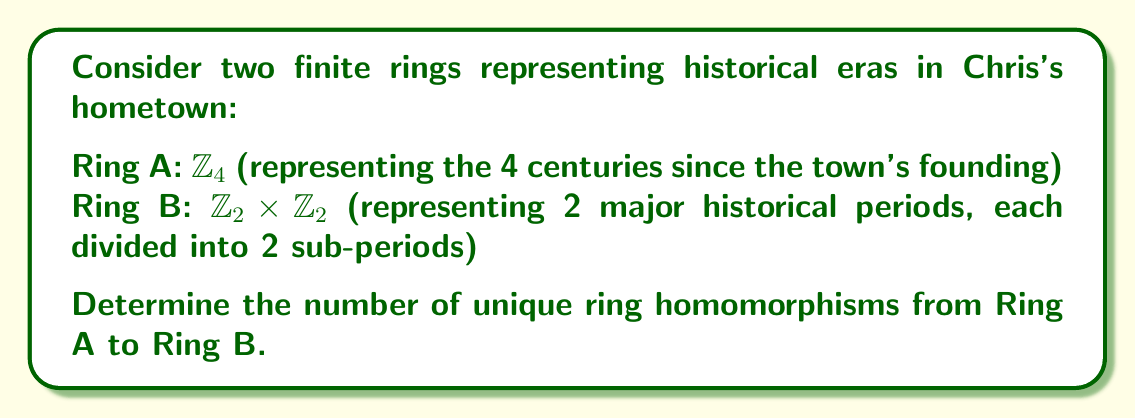Show me your answer to this math problem. 1) First, recall that a ring homomorphism $f: \mathbb{Z}_4 \to \mathbb{Z}_2 \times \mathbb{Z}_2$ must satisfy:
   a) $f(0) = (0,0)$
   b) $f(a+b) = f(a) + f(b)$
   c) $f(ab) = f(a)f(b)$

2) In $\mathbb{Z}_4$, we only need to determine $f(1)$, as:
   $f(2) = f(1+1) = f(1) + f(1)$
   $f(3) = f(-1) = -f(1)$

3) The possible values for $f(1)$ in $\mathbb{Z}_2 \times \mathbb{Z}_2$ are:
   $(0,0)$, $(1,0)$, $(0,1)$, $(1,1)$

4) Check each possibility:
   a) If $f(1) = (0,0)$:
      $f(2) = (0,0) + (0,0) = (0,0)$
      $f(3) = -(0,0) = (0,0)$
      This satisfies all conditions.

   b) If $f(1) = (1,0)$:
      $f(2) = (1,0) + (1,0) = (0,0)$
      $f(3) = -(1,0) = (1,0)$
      This satisfies all conditions.

   c) If $f(1) = (0,1)$:
      $f(2) = (0,1) + (0,1) = (0,0)$
      $f(3) = -(0,1) = (0,1)$
      This satisfies all conditions.

   d) If $f(1) = (1,1)$:
      $f(2) = (1,1) + (1,1) = (0,0)$
      $f(3) = -(1,1) = (1,1)$
      This satisfies all conditions.

5) All four possibilities result in valid ring homomorphisms.

Therefore, there are 4 unique ring homomorphisms from $\mathbb{Z}_4$ to $\mathbb{Z}_2 \times \mathbb{Z}_2$.
Answer: 4 